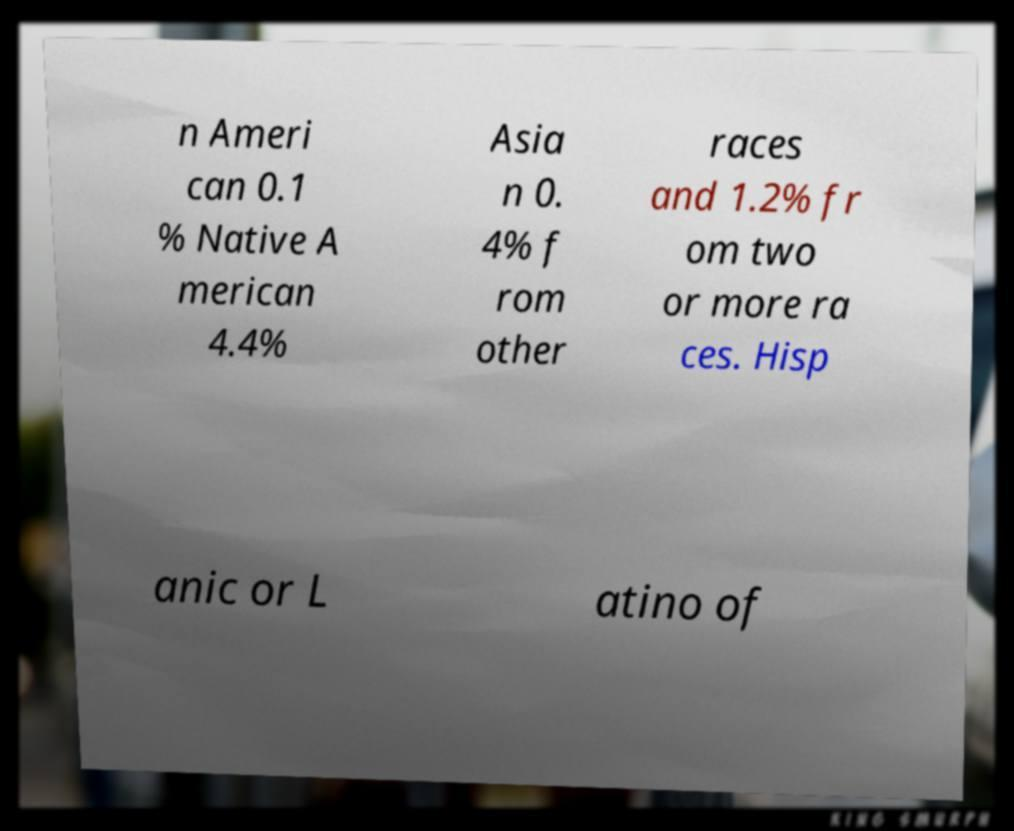Can you read and provide the text displayed in the image?This photo seems to have some interesting text. Can you extract and type it out for me? n Ameri can 0.1 % Native A merican 4.4% Asia n 0. 4% f rom other races and 1.2% fr om two or more ra ces. Hisp anic or L atino of 